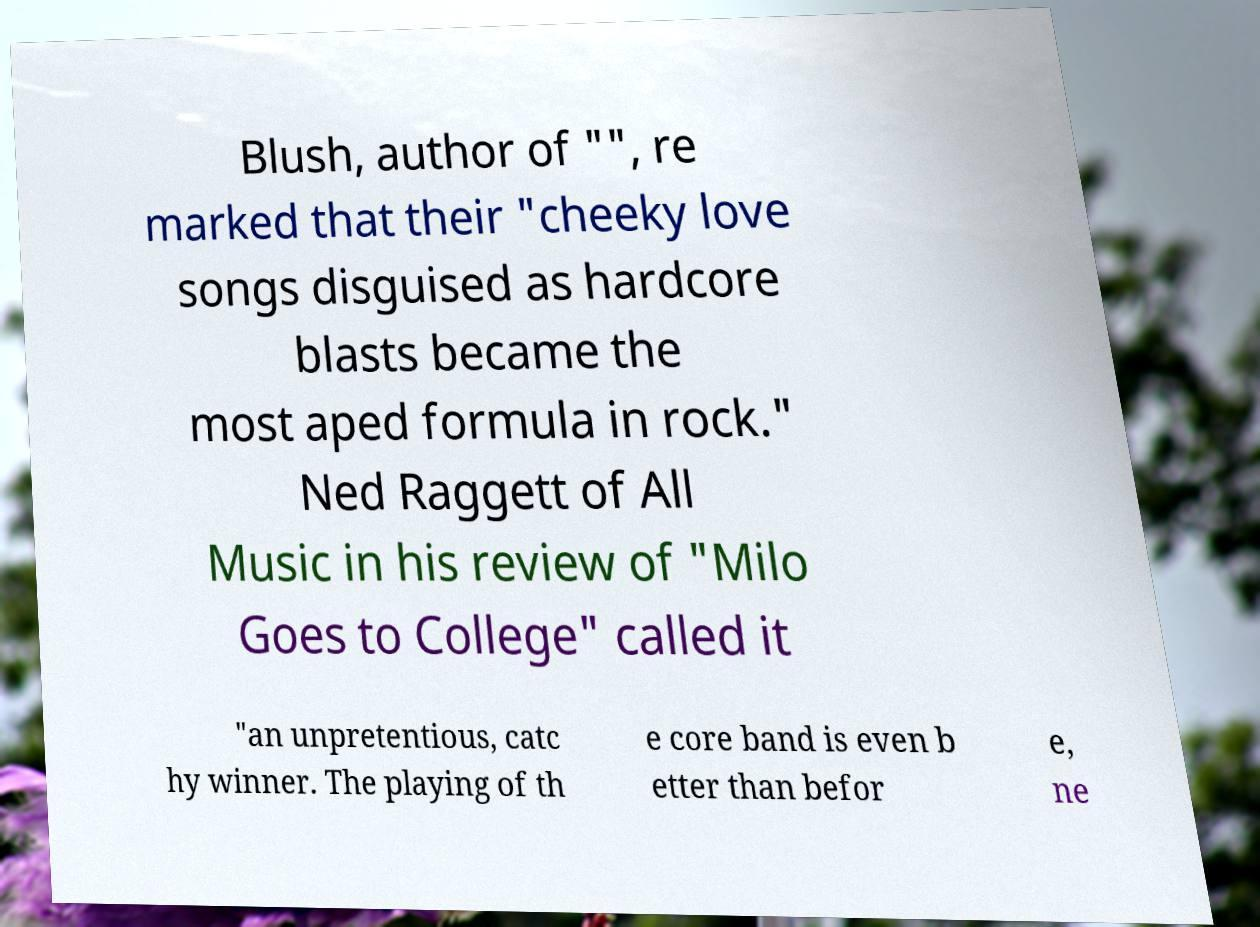What messages or text are displayed in this image? I need them in a readable, typed format. Blush, author of "", re marked that their "cheeky love songs disguised as hardcore blasts became the most aped formula in rock." Ned Raggett of All Music in his review of "Milo Goes to College" called it "an unpretentious, catc hy winner. The playing of th e core band is even b etter than befor e, ne 